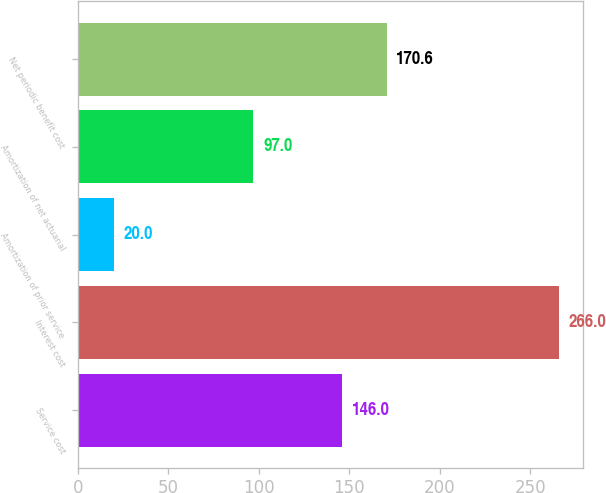<chart> <loc_0><loc_0><loc_500><loc_500><bar_chart><fcel>Service cost<fcel>Interest cost<fcel>Amortization of prior service<fcel>Amortization of net actuarial<fcel>Net periodic benefit cost<nl><fcel>146<fcel>266<fcel>20<fcel>97<fcel>170.6<nl></chart> 